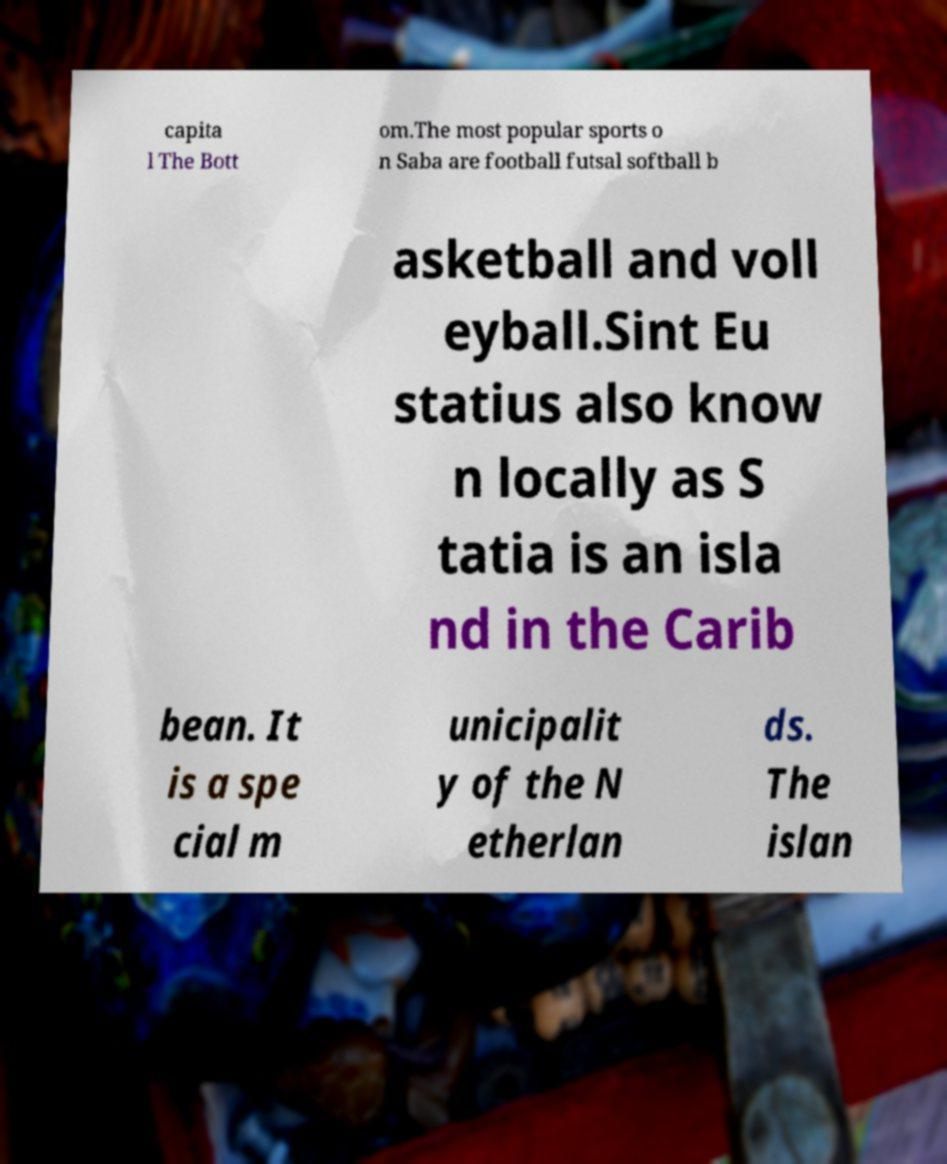Please identify and transcribe the text found in this image. capita l The Bott om.The most popular sports o n Saba are football futsal softball b asketball and voll eyball.Sint Eu statius also know n locally as S tatia is an isla nd in the Carib bean. It is a spe cial m unicipalit y of the N etherlan ds. The islan 